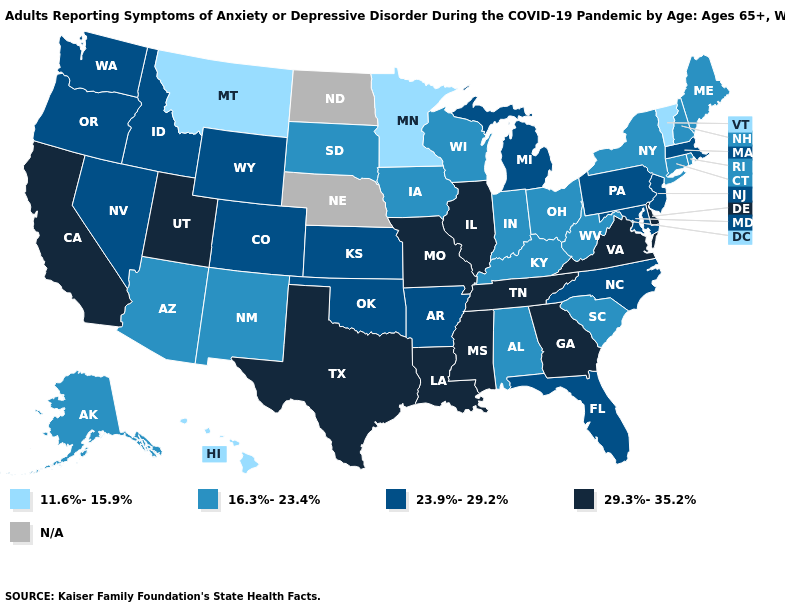Does Minnesota have the lowest value in the USA?
Concise answer only. Yes. Which states have the highest value in the USA?
Write a very short answer. California, Delaware, Georgia, Illinois, Louisiana, Mississippi, Missouri, Tennessee, Texas, Utah, Virginia. Name the states that have a value in the range 29.3%-35.2%?
Quick response, please. California, Delaware, Georgia, Illinois, Louisiana, Mississippi, Missouri, Tennessee, Texas, Utah, Virginia. What is the highest value in the USA?
Short answer required. 29.3%-35.2%. Is the legend a continuous bar?
Quick response, please. No. Does Iowa have the highest value in the MidWest?
Short answer required. No. Name the states that have a value in the range 29.3%-35.2%?
Quick response, please. California, Delaware, Georgia, Illinois, Louisiana, Mississippi, Missouri, Tennessee, Texas, Utah, Virginia. Does New Jersey have the highest value in the Northeast?
Give a very brief answer. Yes. Does Maine have the highest value in the Northeast?
Answer briefly. No. Name the states that have a value in the range 29.3%-35.2%?
Concise answer only. California, Delaware, Georgia, Illinois, Louisiana, Mississippi, Missouri, Tennessee, Texas, Utah, Virginia. Among the states that border Idaho , does Montana have the lowest value?
Keep it brief. Yes. Is the legend a continuous bar?
Answer briefly. No. 